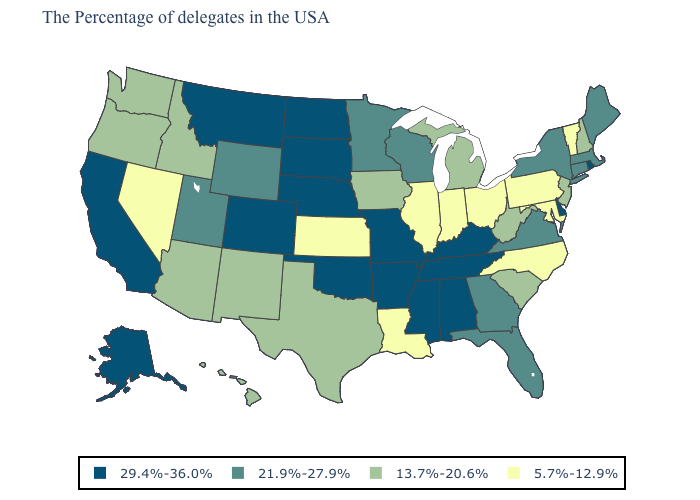What is the value of Pennsylvania?
Short answer required. 5.7%-12.9%. Which states hav the highest value in the Northeast?
Answer briefly. Rhode Island. Name the states that have a value in the range 5.7%-12.9%?
Be succinct. Vermont, Maryland, Pennsylvania, North Carolina, Ohio, Indiana, Illinois, Louisiana, Kansas, Nevada. Name the states that have a value in the range 29.4%-36.0%?
Give a very brief answer. Rhode Island, Delaware, Kentucky, Alabama, Tennessee, Mississippi, Missouri, Arkansas, Nebraska, Oklahoma, South Dakota, North Dakota, Colorado, Montana, California, Alaska. What is the lowest value in states that border Wyoming?
Quick response, please. 13.7%-20.6%. What is the value of Illinois?
Short answer required. 5.7%-12.9%. Which states hav the highest value in the MidWest?
Answer briefly. Missouri, Nebraska, South Dakota, North Dakota. What is the lowest value in the USA?
Concise answer only. 5.7%-12.9%. What is the value of Iowa?
Quick response, please. 13.7%-20.6%. What is the value of Missouri?
Be succinct. 29.4%-36.0%. Which states have the lowest value in the USA?
Be succinct. Vermont, Maryland, Pennsylvania, North Carolina, Ohio, Indiana, Illinois, Louisiana, Kansas, Nevada. Which states have the lowest value in the West?
Concise answer only. Nevada. Does New Jersey have the highest value in the Northeast?
Short answer required. No. Does Colorado have the highest value in the USA?
Be succinct. Yes. What is the value of Montana?
Answer briefly. 29.4%-36.0%. 